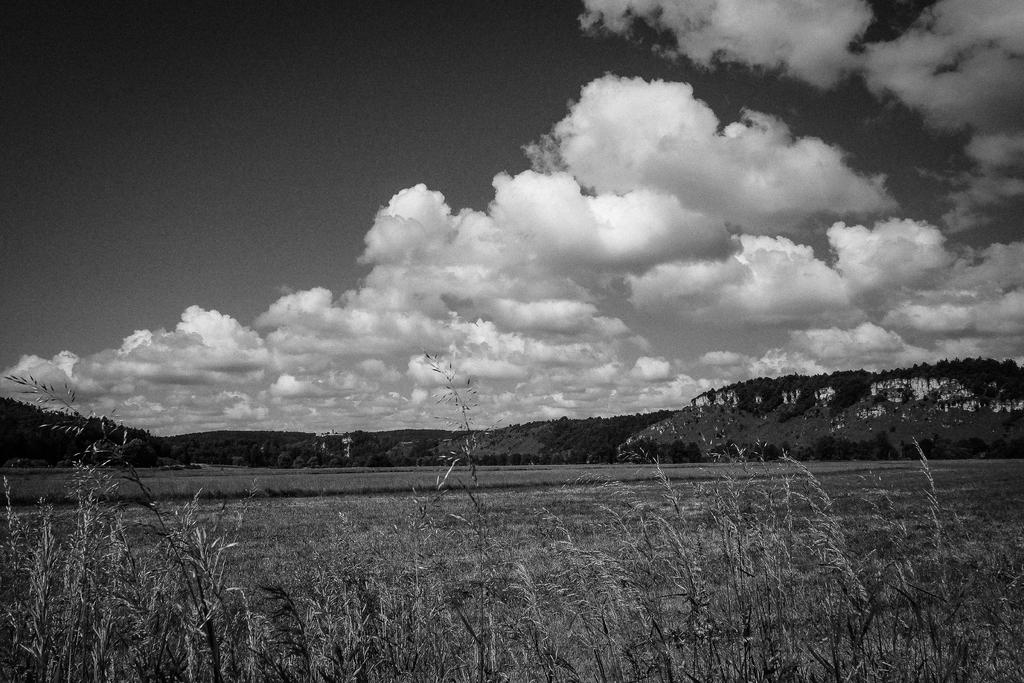What type of vegetation is present in the image? There is grass and trees in the image. What type of natural landform can be seen in the image? There are mountains in the image. What is visible in the sky in the image? The sky is visible in the image. What grade of tomatoes can be seen growing on the mountains in the image? There are no tomatoes present in the image, and the mountains do not have any visible crops. 